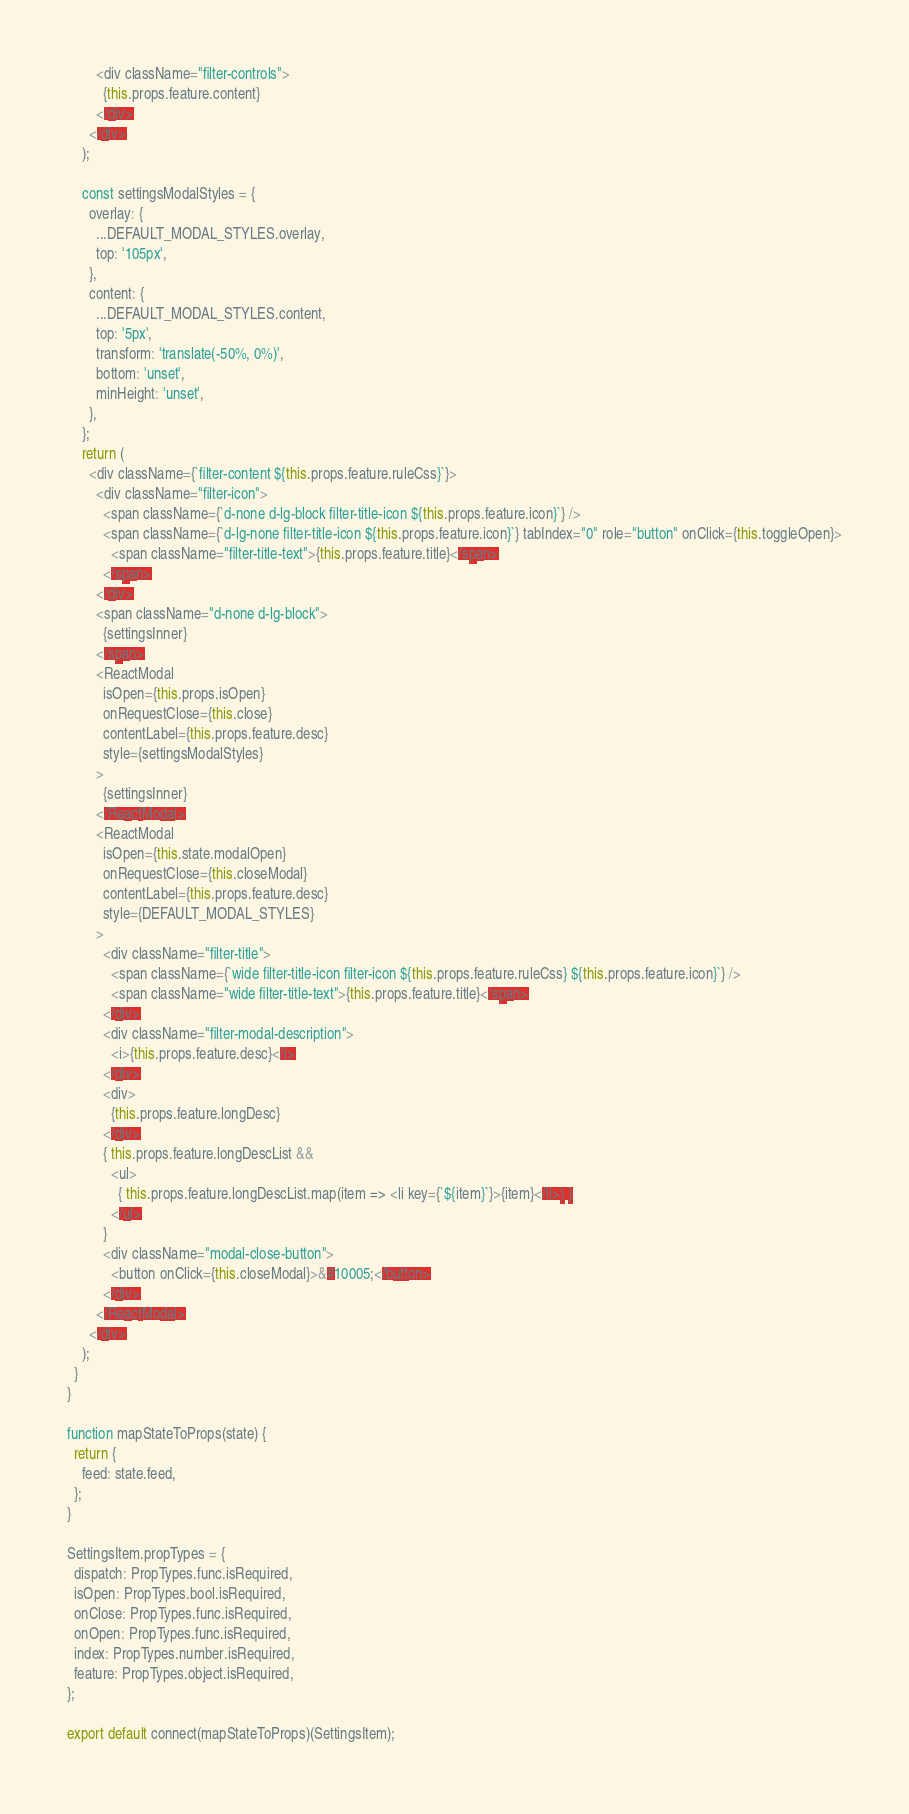<code> <loc_0><loc_0><loc_500><loc_500><_JavaScript_>        <div className="filter-controls">
          {this.props.feature.content}
        </div>
      </div>
    );

    const settingsModalStyles = {
      overlay: {
        ...DEFAULT_MODAL_STYLES.overlay,
        top: '105px',
      },
      content: {
        ...DEFAULT_MODAL_STYLES.content,
        top: '5px',
        transform: 'translate(-50%, 0%)',
        bottom: 'unset',
        minHeight: 'unset',
      },
    };
    return (
      <div className={`filter-content ${this.props.feature.ruleCss}`}>
        <div className="filter-icon">
          <span className={`d-none d-lg-block filter-title-icon ${this.props.feature.icon}`} />
          <span className={`d-lg-none filter-title-icon ${this.props.feature.icon}`} tabIndex="0" role="button" onClick={this.toggleOpen}>
            <span className="filter-title-text">{this.props.feature.title}</span>
          </span>
        </div>
        <span className="d-none d-lg-block">
          {settingsInner}
        </span>
        <ReactModal
          isOpen={this.props.isOpen}
          onRequestClose={this.close}
          contentLabel={this.props.feature.desc}
          style={settingsModalStyles}
        >
          {settingsInner}
        </ReactModal>
        <ReactModal
          isOpen={this.state.modalOpen}
          onRequestClose={this.closeModal}
          contentLabel={this.props.feature.desc}
          style={DEFAULT_MODAL_STYLES}
        >
          <div className="filter-title">
            <span className={`wide filter-title-icon filter-icon ${this.props.feature.ruleCss} ${this.props.feature.icon}`} />
            <span className="wide filter-title-text">{this.props.feature.title}</span>
          </div>
          <div className="filter-modal-description">
            <i>{this.props.feature.desc}</i>
          </div>
          <div>
            {this.props.feature.longDesc}
          </div>
          { this.props.feature.longDescList &&
            <ul>
              { this.props.feature.longDescList.map(item => <li key={`${item}`}>{item}</li>) }
            </ul>
          }
          <div className="modal-close-button">
            <button onClick={this.closeModal}>&#10005;</button>
          </div>
        </ReactModal>
      </div>
    );
  }
}

function mapStateToProps(state) {
  return {
    feed: state.feed,
  };
}

SettingsItem.propTypes = {
  dispatch: PropTypes.func.isRequired,
  isOpen: PropTypes.bool.isRequired,
  onClose: PropTypes.func.isRequired,
  onOpen: PropTypes.func.isRequired,
  index: PropTypes.number.isRequired,
  feature: PropTypes.object.isRequired,
};

export default connect(mapStateToProps)(SettingsItem);
</code> 